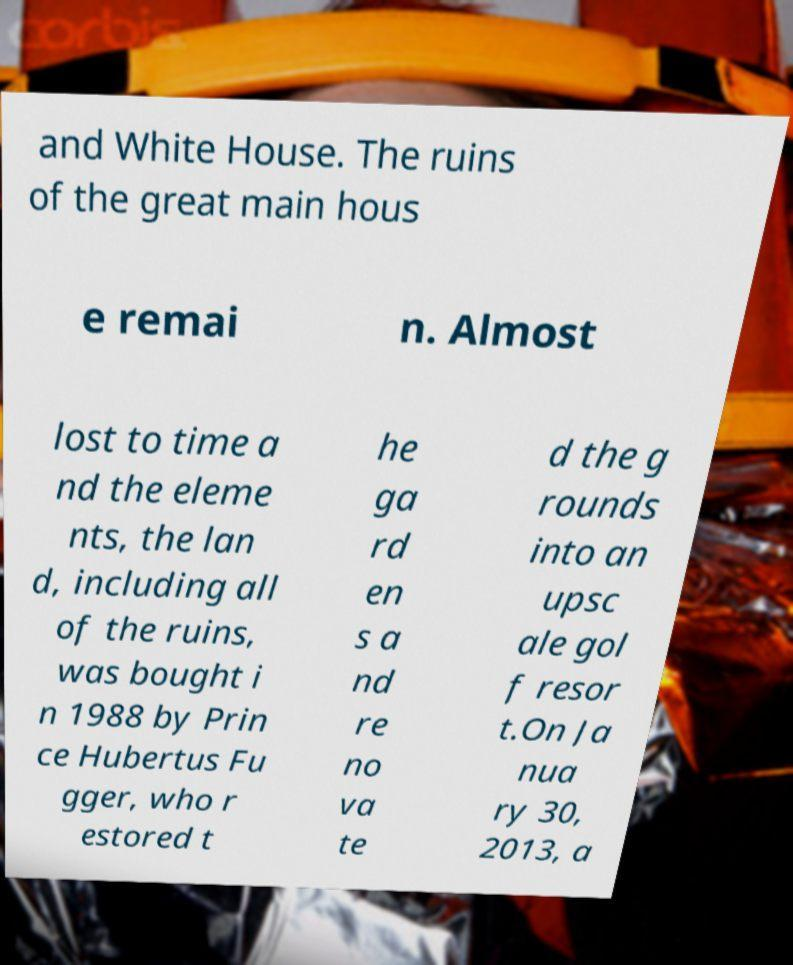Please identify and transcribe the text found in this image. and White House. The ruins of the great main hous e remai n. Almost lost to time a nd the eleme nts, the lan d, including all of the ruins, was bought i n 1988 by Prin ce Hubertus Fu gger, who r estored t he ga rd en s a nd re no va te d the g rounds into an upsc ale gol f resor t.On Ja nua ry 30, 2013, a 